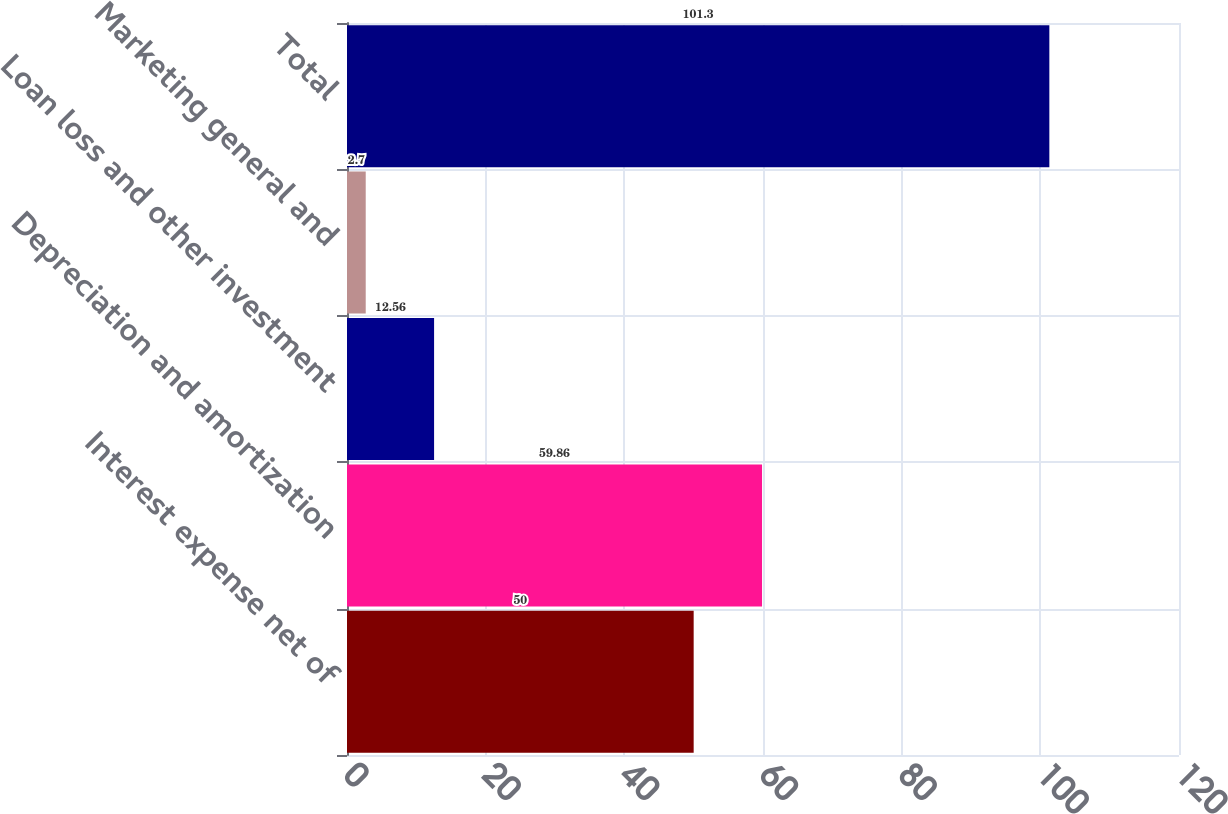Convert chart. <chart><loc_0><loc_0><loc_500><loc_500><bar_chart><fcel>Interest expense net of<fcel>Depreciation and amortization<fcel>Loan loss and other investment<fcel>Marketing general and<fcel>Total<nl><fcel>50<fcel>59.86<fcel>12.56<fcel>2.7<fcel>101.3<nl></chart> 